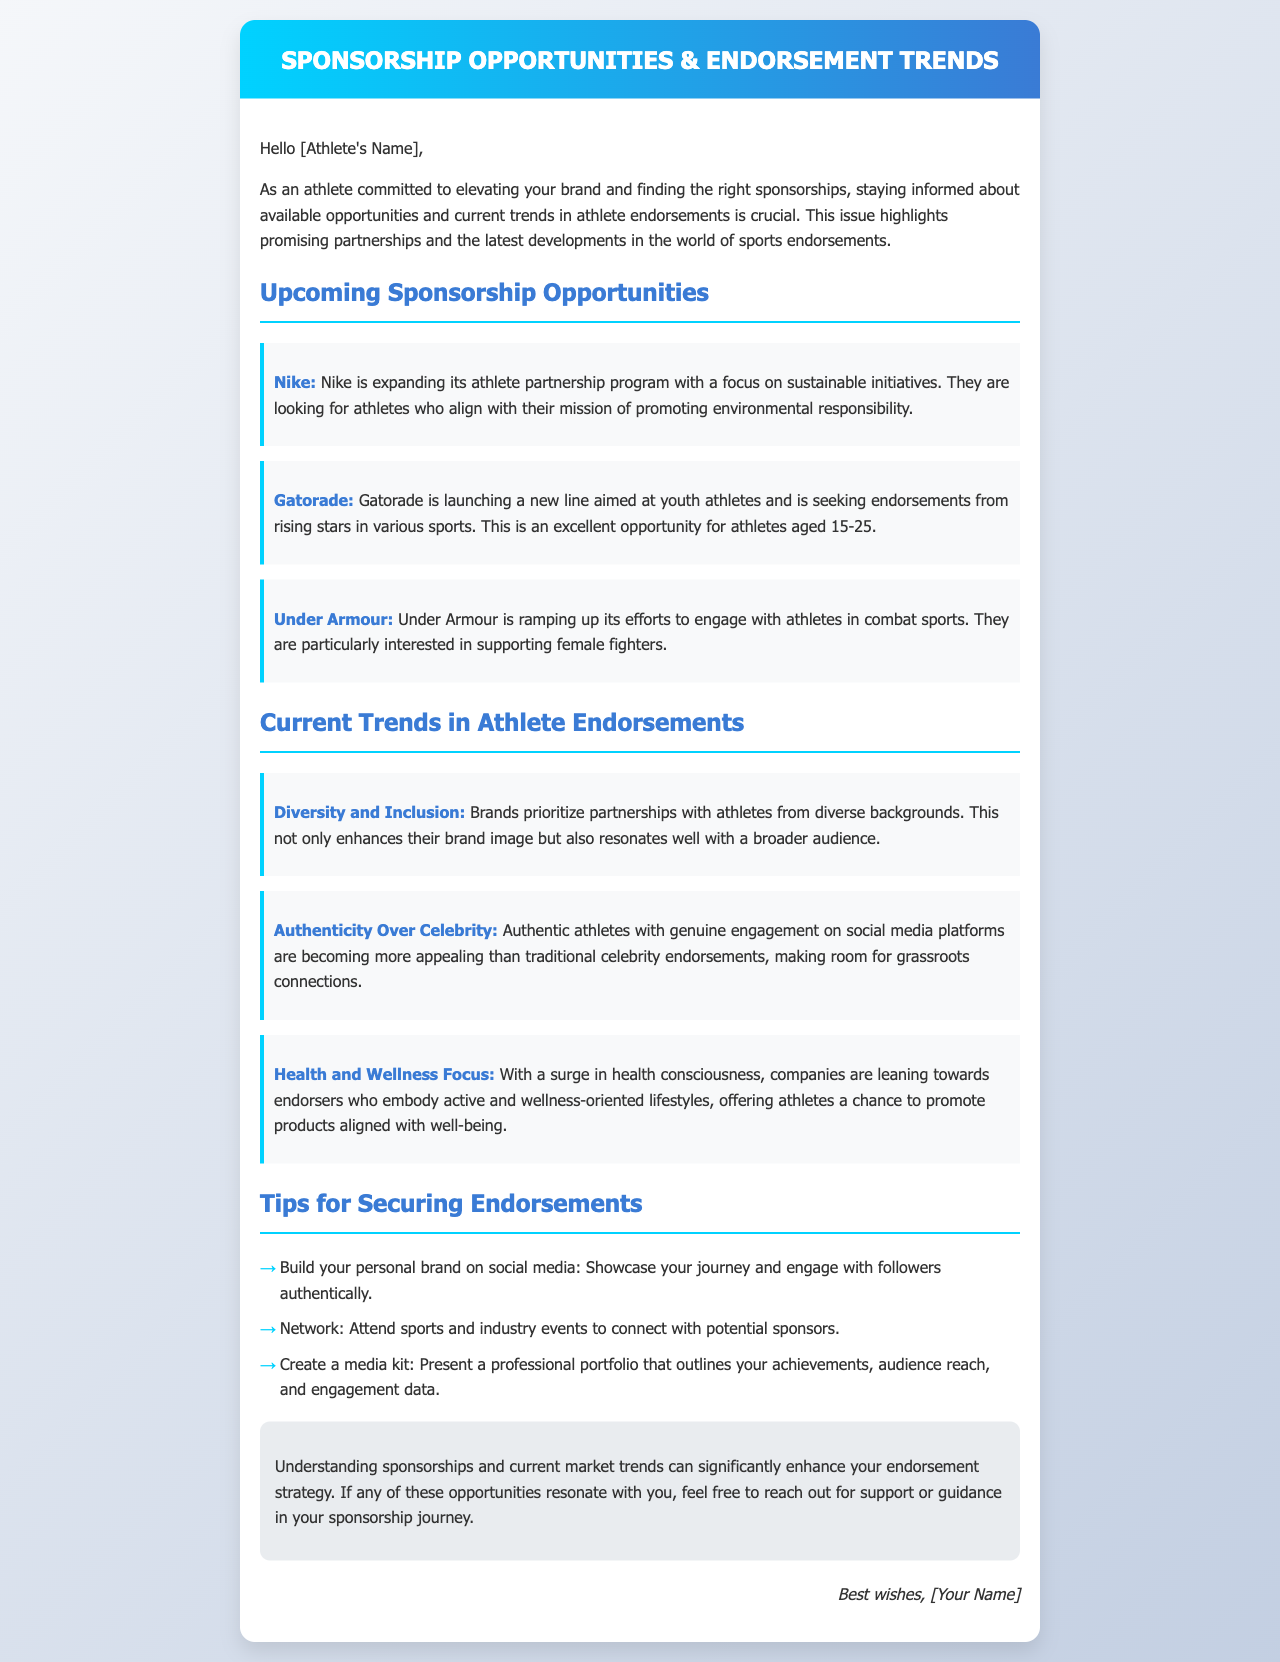What brand is expanding its athlete partnership program? The document mentions Nike as the brand expanding its athlete partnership program with a focus on sustainable initiatives.
Answer: Nike What age group is Gatorade targeting for endorsements? Gatorade is seeking endorsements from athletes aged 15-25 for their new line aimed at youth athletes.
Answer: 15-25 Which brand is interested in supporting female fighters? According to the document, Under Armour is ramping up its efforts to support female fighters in combat sports.
Answer: Under Armour What trend are brands prioritizing in partnerships? The document states that brands are prioritizing diversity and inclusion in partnerships with athletes from diverse backgrounds.
Answer: Diversity and Inclusion What should athletes create to present their achievements professionally? The document suggests that athletes should create a media kit to present a professional portfolio outlining their achievements.
Answer: Media kit 